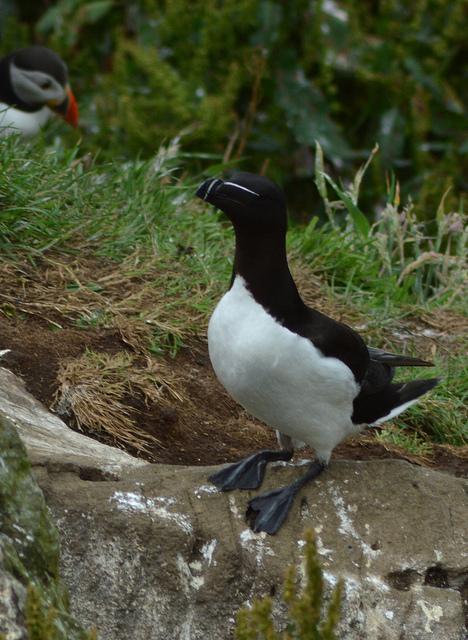What is the green plant matter behind the bird?
Answer briefly. Grass. Is this photo outdoors?
Give a very brief answer. Yes. What animal is in this picture?
Concise answer only. Bird. 